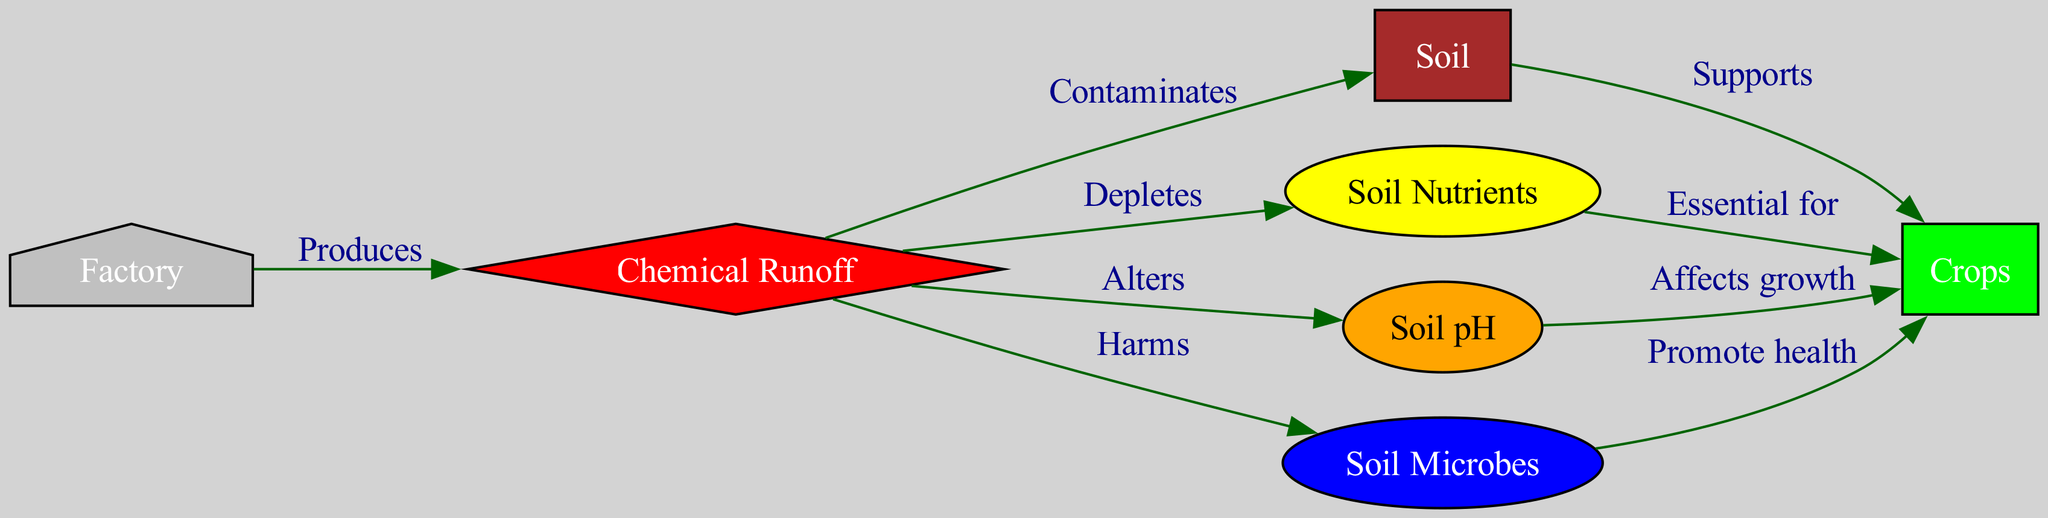What are the nodes in the diagram? The nodes in the diagram are the individual components represented, namely the factory, chemical runoff, soil, crops, soil nutrients, soil pH, and soil microbes. One can count these labeled entities to identify the specific nodes.
Answer: factory, chemical runoff, soil, crops, soil nutrients, soil pH, soil microbes How many edges are present in the diagram? The edges represent the relationships between the nodes. By examining the connections drawn in the diagram, one can easily count all the arrows that connect different nodes. In this case, there are a total of 9 edges.
Answer: 9 What does the runoff do to soil? The diagram indicates that chemical runoff contaminates the soil, which is specified through the labeled edge connecting these two nodes. The relationship is explicitly stated.
Answer: Contaminates How do nutrients affect crop growth? According to the diagram, soil nutrients are essential for crops, as highlighted in the relationship depicted by the edge connecting these two nodes, which indicates their supportive role for crop growth.
Answer: Essential for What harmful impact does runoff have on microbes? The edge between chemical runoff and soil microbes illustrates that runoff harms the microbes. The phrase pointed out on this edge clearly expresses the negative effect that runoff has on soil microbes.
Answer: Harms How does runoff alter soil pH? The diagram shows that chemical runoff affects soil pH, specifically indicating that it alters this characteristic in the soil. This is also defined by the edge linking the runoff to the soil pH node based on the labeled relationship.
Answer: Alters Which node supports crops? The diagram shows that soil supports crops, which is specified through the edge connecting the soil node to the crops node, indicating the supportive relationship between these entities.
Answer: Soil What do microbes do for crops? The diagram states that soil microbes promote the health of crops. This relationship is detailed in the edge that connects these two nodes, specifying the positive contribution of microbes to crop well-being.
Answer: Promote health What is produced by the factory? The diagram indicates that the factory produces chemical runoff. This is evident from the edge that originates at the factory node and points to the runoff node, clearly labeling the relationship.
Answer: Chemical runoff 